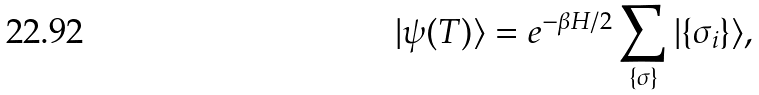Convert formula to latex. <formula><loc_0><loc_0><loc_500><loc_500>| \psi ( T ) \rangle = e ^ { - \beta H / 2 } \sum _ { \{ \sigma \} } | \{ \sigma _ { i } \} \rangle ,</formula> 